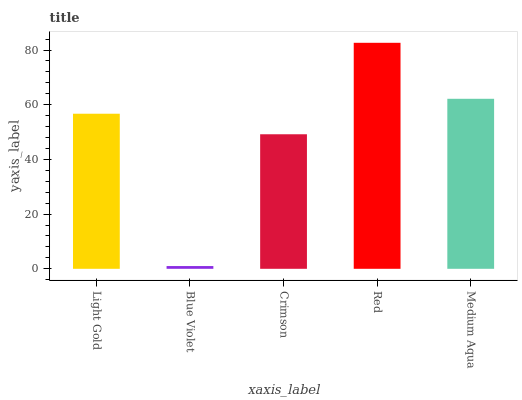Is Blue Violet the minimum?
Answer yes or no. Yes. Is Red the maximum?
Answer yes or no. Yes. Is Crimson the minimum?
Answer yes or no. No. Is Crimson the maximum?
Answer yes or no. No. Is Crimson greater than Blue Violet?
Answer yes or no. Yes. Is Blue Violet less than Crimson?
Answer yes or no. Yes. Is Blue Violet greater than Crimson?
Answer yes or no. No. Is Crimson less than Blue Violet?
Answer yes or no. No. Is Light Gold the high median?
Answer yes or no. Yes. Is Light Gold the low median?
Answer yes or no. Yes. Is Blue Violet the high median?
Answer yes or no. No. Is Medium Aqua the low median?
Answer yes or no. No. 